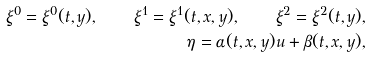Convert formula to latex. <formula><loc_0><loc_0><loc_500><loc_500>\xi ^ { 0 } = \xi ^ { 0 } ( t , y ) , \quad \xi ^ { 1 } = \xi ^ { 1 } ( t , x , y ) , \quad \xi ^ { 2 } = \xi ^ { 2 } ( t , y ) , \\ \eta = \alpha ( t , x , y ) u + \beta ( t , x , y ) ,</formula> 